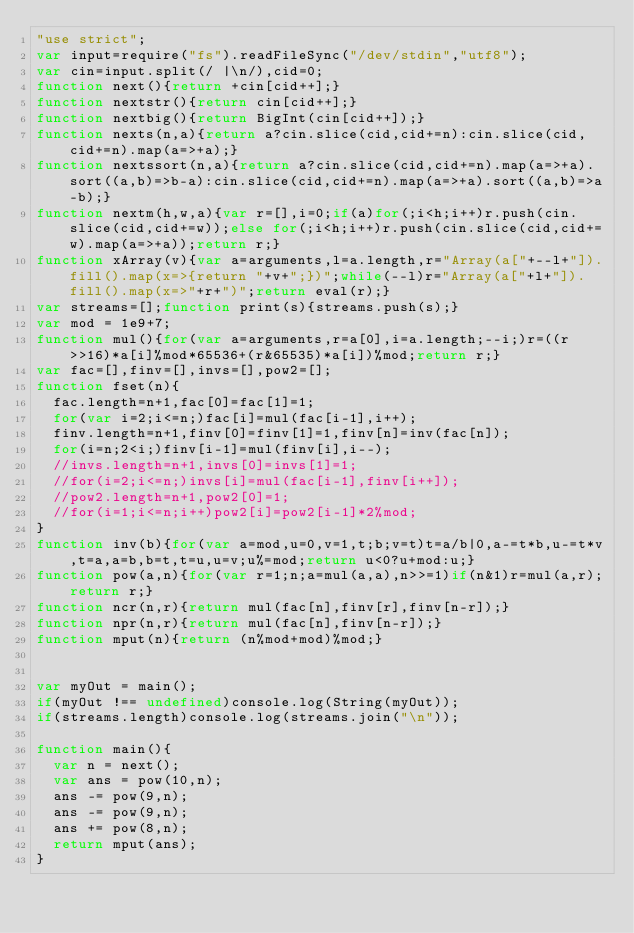Convert code to text. <code><loc_0><loc_0><loc_500><loc_500><_JavaScript_>"use strict";
var input=require("fs").readFileSync("/dev/stdin","utf8");
var cin=input.split(/ |\n/),cid=0;
function next(){return +cin[cid++];}
function nextstr(){return cin[cid++];}
function nextbig(){return BigInt(cin[cid++]);}
function nexts(n,a){return a?cin.slice(cid,cid+=n):cin.slice(cid,cid+=n).map(a=>+a);}
function nextssort(n,a){return a?cin.slice(cid,cid+=n).map(a=>+a).sort((a,b)=>b-a):cin.slice(cid,cid+=n).map(a=>+a).sort((a,b)=>a-b);}
function nextm(h,w,a){var r=[],i=0;if(a)for(;i<h;i++)r.push(cin.slice(cid,cid+=w));else for(;i<h;i++)r.push(cin.slice(cid,cid+=w).map(a=>+a));return r;}
function xArray(v){var a=arguments,l=a.length,r="Array(a["+--l+"]).fill().map(x=>{return "+v+";})";while(--l)r="Array(a["+l+"]).fill().map(x=>"+r+")";return eval(r);}
var streams=[];function print(s){streams.push(s);}
var mod = 1e9+7;
function mul(){for(var a=arguments,r=a[0],i=a.length;--i;)r=((r>>16)*a[i]%mod*65536+(r&65535)*a[i])%mod;return r;}
var fac=[],finv=[],invs=[],pow2=[];
function fset(n){
  fac.length=n+1,fac[0]=fac[1]=1;
  for(var i=2;i<=n;)fac[i]=mul(fac[i-1],i++);
  finv.length=n+1,finv[0]=finv[1]=1,finv[n]=inv(fac[n]);
  for(i=n;2<i;)finv[i-1]=mul(finv[i],i--);
  //invs.length=n+1,invs[0]=invs[1]=1;
  //for(i=2;i<=n;)invs[i]=mul(fac[i-1],finv[i++]);
  //pow2.length=n+1,pow2[0]=1;
  //for(i=1;i<=n;i++)pow2[i]=pow2[i-1]*2%mod;
}
function inv(b){for(var a=mod,u=0,v=1,t;b;v=t)t=a/b|0,a-=t*b,u-=t*v,t=a,a=b,b=t,t=u,u=v;u%=mod;return u<0?u+mod:u;}
function pow(a,n){for(var r=1;n;a=mul(a,a),n>>=1)if(n&1)r=mul(a,r);return r;}
function ncr(n,r){return mul(fac[n],finv[r],finv[n-r]);}
function npr(n,r){return mul(fac[n],finv[n-r]);}
function mput(n){return (n%mod+mod)%mod;}


var myOut = main();
if(myOut !== undefined)console.log(String(myOut));
if(streams.length)console.log(streams.join("\n"));

function main(){
  var n = next();
  var ans = pow(10,n);
  ans -= pow(9,n);
  ans -= pow(9,n);
  ans += pow(8,n);
  return mput(ans);
}</code> 